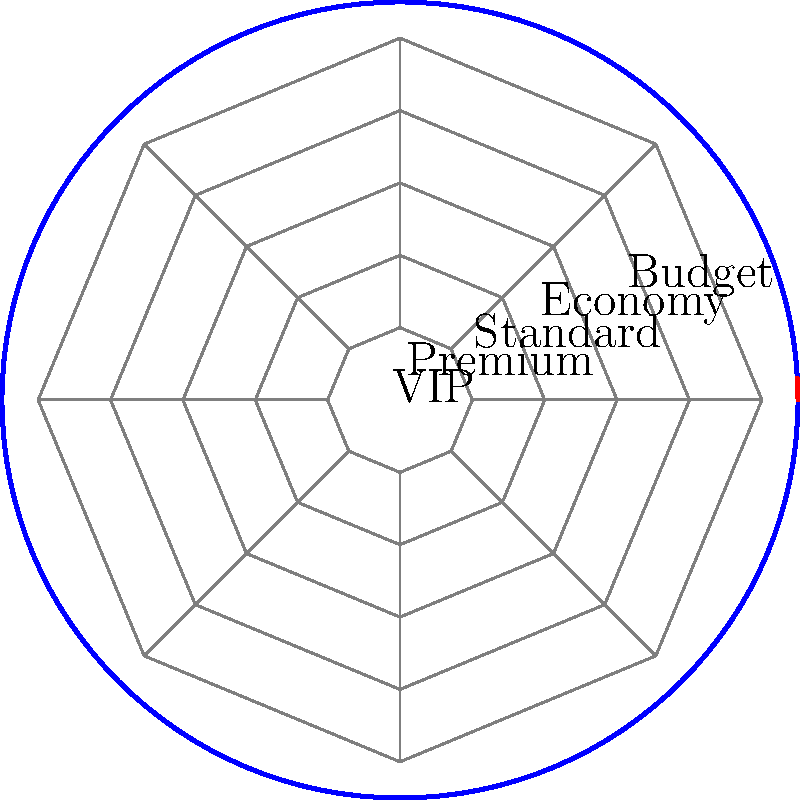In this polar coordinate representation of a football stadium, which seating section is closest to the pitch, and how might this arrangement conflict with FIFA's stance on equal access for fans? To answer this question, let's analyze the polar coordinate representation of the stadium:

1. The stadium is divided into 5 concentric circular sections, representing different seating categories.

2. The sections, from innermost to outermost, are labeled:
   a) VIP
   b) Premium
   c) Standard
   d) Economy
   e) Budget

3. The VIP section is closest to the center, which represents the pitch in this diagram.

4. FIFA has often claimed to promote equal access and fairness for all fans. However, this seating arrangement clearly prioritizes wealthy spectators by placing them closest to the action.

5. The stark segregation of fans based on ticket prices conflicts with the idea of football as a unifying sport for all social classes.

6. This arrangement could be seen as contradicting FIFA's stated goals of inclusivity and accessibility, as it physically separates fans based on their economic status.

7. Critics might argue that this seating plan exemplifies how commercialization in football, often supported by FIFA's policies, can lead to increased inequality in the fan experience.
Answer: VIP section; contradicts equal access principles 